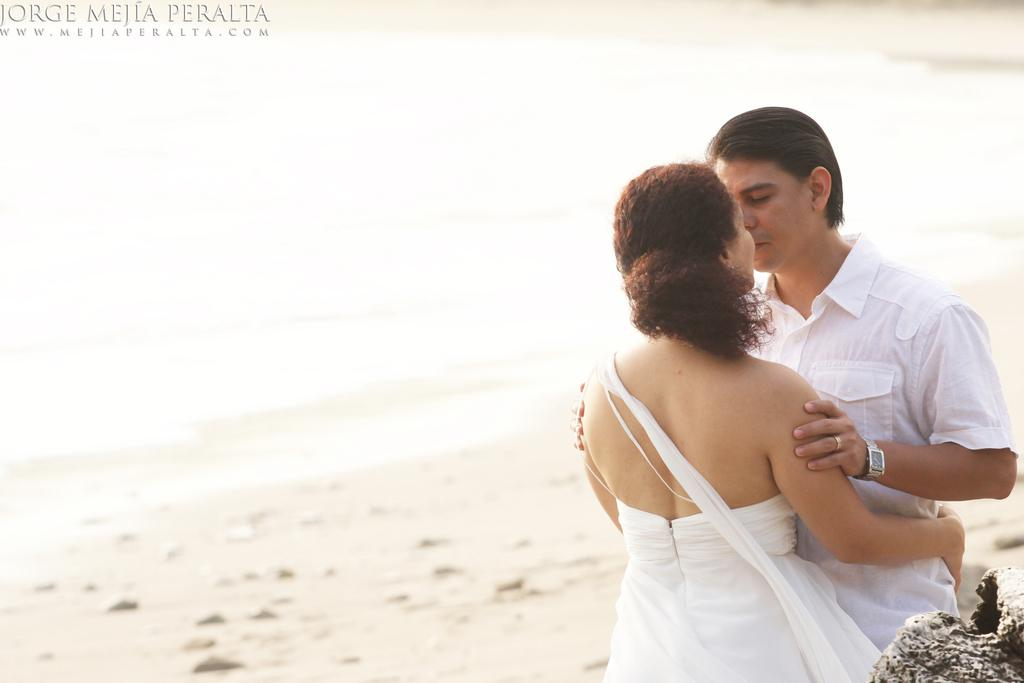How many people are in the image? There are two people in the image. What are the people doing in the image? Both people are standing. What color are the dresses worn by the people in the image? Both people are wearing white color dresses. What can be seen in the background of the image? There is sand visible in the background of the image. What is the color of the background in the image? The background of the image is white. What type of food is being served on the wooden plate in the image? There is no wooden plate or food present in the image. How many roses are visible in the image? There are no roses visible in the image. 